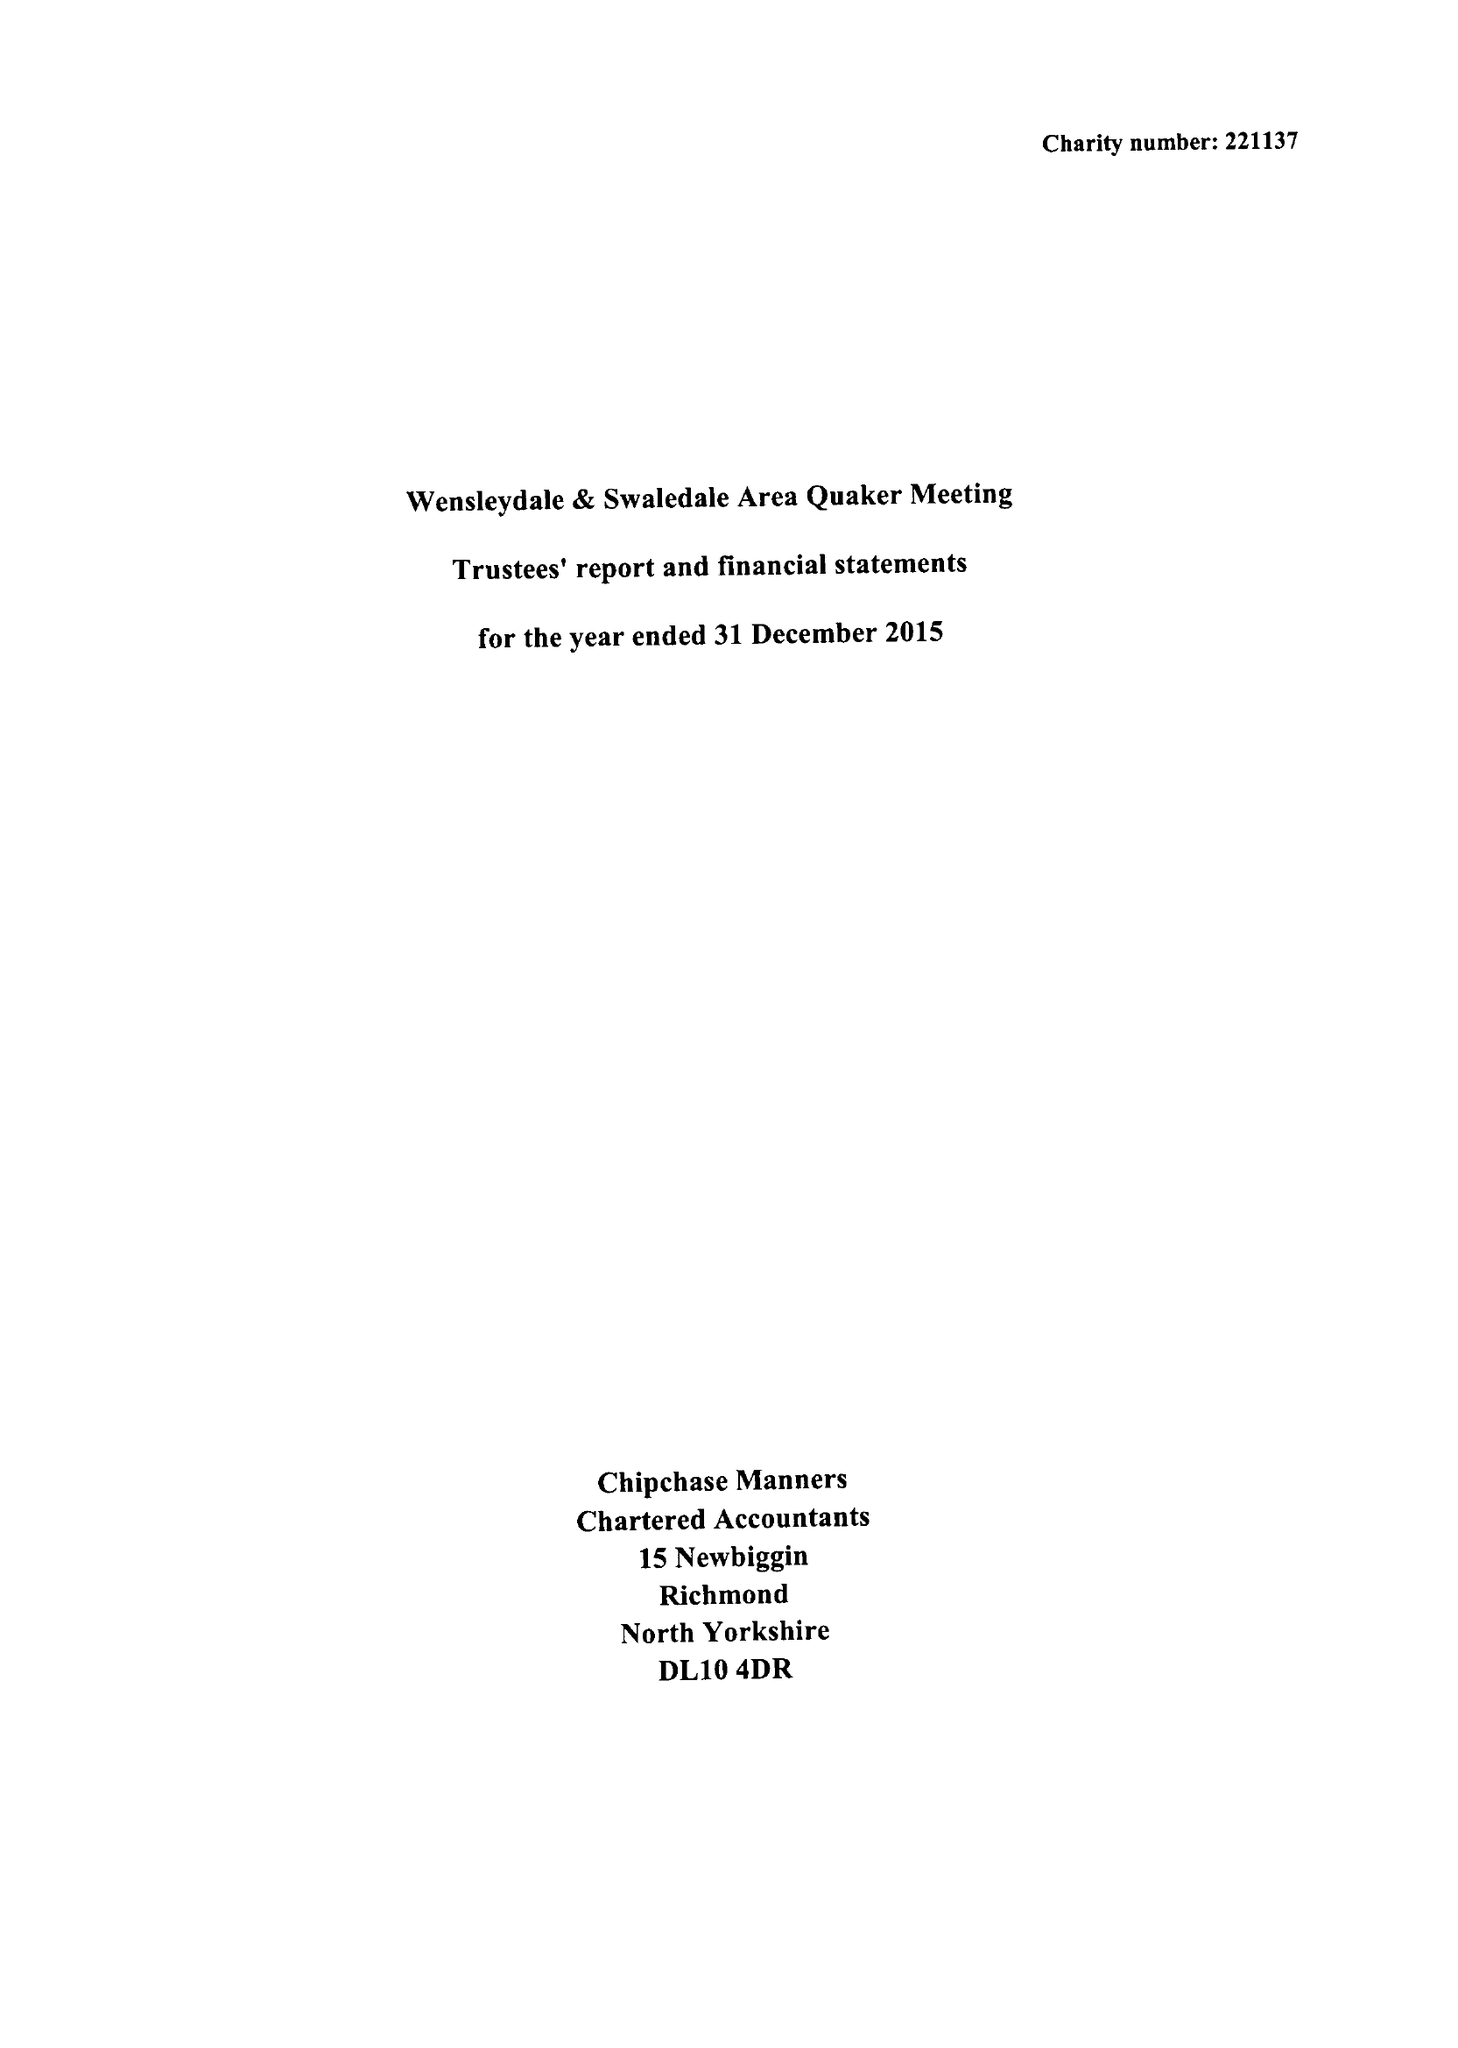What is the value for the spending_annually_in_british_pounds?
Answer the question using a single word or phrase. 48738.00 